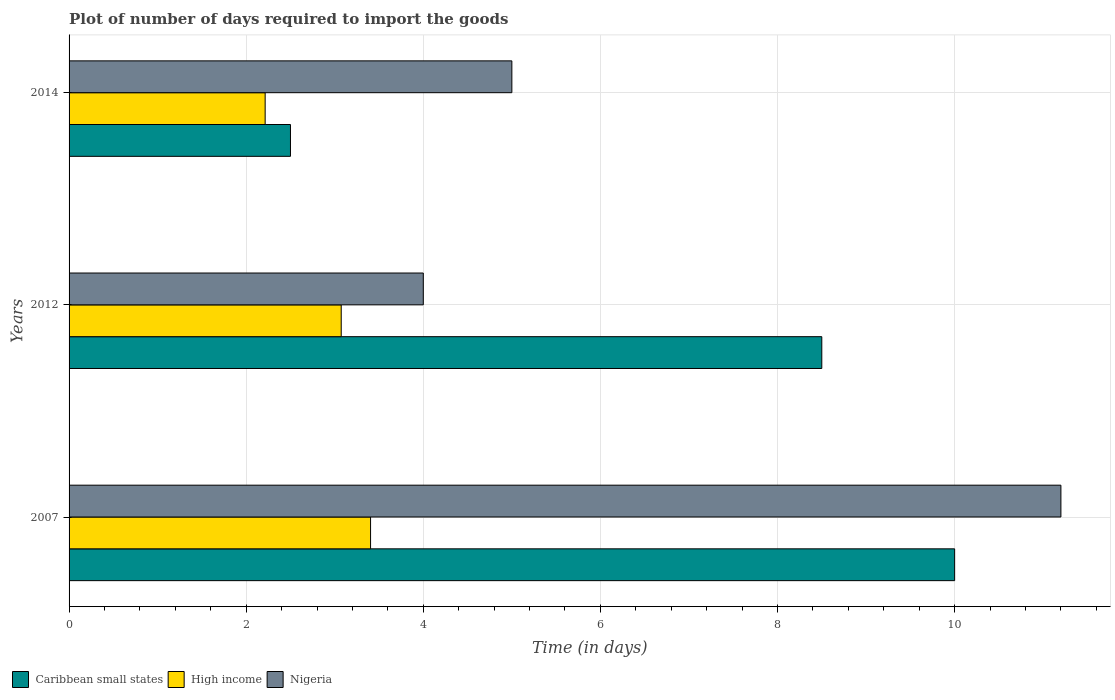How many different coloured bars are there?
Keep it short and to the point. 3. How many groups of bars are there?
Keep it short and to the point. 3. How many bars are there on the 3rd tick from the bottom?
Give a very brief answer. 3. What is the label of the 2nd group of bars from the top?
Keep it short and to the point. 2012. What is the time required to import goods in High income in 2012?
Keep it short and to the point. 3.07. Across all years, what is the maximum time required to import goods in Caribbean small states?
Ensure brevity in your answer.  10. Across all years, what is the minimum time required to import goods in High income?
Keep it short and to the point. 2.21. What is the difference between the time required to import goods in Nigeria in 2014 and the time required to import goods in High income in 2012?
Your answer should be compact. 1.93. What is the average time required to import goods in Nigeria per year?
Ensure brevity in your answer.  6.73. In the year 2014, what is the difference between the time required to import goods in Nigeria and time required to import goods in Caribbean small states?
Give a very brief answer. 2.5. What is the ratio of the time required to import goods in High income in 2007 to that in 2012?
Offer a terse response. 1.11. Is the time required to import goods in Caribbean small states in 2007 less than that in 2014?
Your answer should be compact. No. Is the difference between the time required to import goods in Nigeria in 2012 and 2014 greater than the difference between the time required to import goods in Caribbean small states in 2012 and 2014?
Make the answer very short. No. What is the difference between the highest and the second highest time required to import goods in Nigeria?
Your answer should be compact. 6.2. In how many years, is the time required to import goods in Caribbean small states greater than the average time required to import goods in Caribbean small states taken over all years?
Ensure brevity in your answer.  2. What does the 3rd bar from the top in 2012 represents?
Make the answer very short. Caribbean small states. How many years are there in the graph?
Keep it short and to the point. 3. What is the difference between two consecutive major ticks on the X-axis?
Make the answer very short. 2. Does the graph contain any zero values?
Make the answer very short. No. Does the graph contain grids?
Offer a terse response. Yes. Where does the legend appear in the graph?
Your answer should be very brief. Bottom left. How are the legend labels stacked?
Your response must be concise. Horizontal. What is the title of the graph?
Your answer should be very brief. Plot of number of days required to import the goods. What is the label or title of the X-axis?
Provide a short and direct response. Time (in days). What is the label or title of the Y-axis?
Provide a succinct answer. Years. What is the Time (in days) of High income in 2007?
Your response must be concise. 3.4. What is the Time (in days) of Nigeria in 2007?
Your answer should be compact. 11.2. What is the Time (in days) in Caribbean small states in 2012?
Offer a very short reply. 8.5. What is the Time (in days) in High income in 2012?
Ensure brevity in your answer.  3.07. What is the Time (in days) of Nigeria in 2012?
Offer a terse response. 4. What is the Time (in days) in High income in 2014?
Make the answer very short. 2.21. What is the Time (in days) of Nigeria in 2014?
Your answer should be compact. 5. Across all years, what is the maximum Time (in days) of High income?
Provide a succinct answer. 3.4. Across all years, what is the minimum Time (in days) in Caribbean small states?
Your answer should be very brief. 2.5. Across all years, what is the minimum Time (in days) in High income?
Your answer should be compact. 2.21. What is the total Time (in days) in High income in the graph?
Provide a short and direct response. 8.69. What is the total Time (in days) of Nigeria in the graph?
Your answer should be very brief. 20.2. What is the difference between the Time (in days) of High income in 2007 and that in 2012?
Keep it short and to the point. 0.33. What is the difference between the Time (in days) of Caribbean small states in 2007 and that in 2014?
Offer a terse response. 7.5. What is the difference between the Time (in days) of High income in 2007 and that in 2014?
Provide a succinct answer. 1.19. What is the difference between the Time (in days) in High income in 2012 and that in 2014?
Your answer should be very brief. 0.86. What is the difference between the Time (in days) of Caribbean small states in 2007 and the Time (in days) of High income in 2012?
Provide a succinct answer. 6.93. What is the difference between the Time (in days) in Caribbean small states in 2007 and the Time (in days) in Nigeria in 2012?
Your answer should be very brief. 6. What is the difference between the Time (in days) of High income in 2007 and the Time (in days) of Nigeria in 2012?
Your answer should be very brief. -0.6. What is the difference between the Time (in days) of Caribbean small states in 2007 and the Time (in days) of High income in 2014?
Give a very brief answer. 7.79. What is the difference between the Time (in days) of High income in 2007 and the Time (in days) of Nigeria in 2014?
Give a very brief answer. -1.6. What is the difference between the Time (in days) in Caribbean small states in 2012 and the Time (in days) in High income in 2014?
Keep it short and to the point. 6.29. What is the difference between the Time (in days) of Caribbean small states in 2012 and the Time (in days) of Nigeria in 2014?
Your answer should be very brief. 3.5. What is the difference between the Time (in days) in High income in 2012 and the Time (in days) in Nigeria in 2014?
Provide a succinct answer. -1.93. What is the average Time (in days) of High income per year?
Offer a terse response. 2.9. What is the average Time (in days) in Nigeria per year?
Give a very brief answer. 6.73. In the year 2007, what is the difference between the Time (in days) of Caribbean small states and Time (in days) of High income?
Provide a succinct answer. 6.6. In the year 2007, what is the difference between the Time (in days) of High income and Time (in days) of Nigeria?
Your answer should be very brief. -7.8. In the year 2012, what is the difference between the Time (in days) in Caribbean small states and Time (in days) in High income?
Offer a very short reply. 5.43. In the year 2012, what is the difference between the Time (in days) in Caribbean small states and Time (in days) in Nigeria?
Offer a terse response. 4.5. In the year 2012, what is the difference between the Time (in days) of High income and Time (in days) of Nigeria?
Give a very brief answer. -0.93. In the year 2014, what is the difference between the Time (in days) in Caribbean small states and Time (in days) in High income?
Offer a terse response. 0.29. In the year 2014, what is the difference between the Time (in days) of High income and Time (in days) of Nigeria?
Offer a terse response. -2.79. What is the ratio of the Time (in days) of Caribbean small states in 2007 to that in 2012?
Your answer should be very brief. 1.18. What is the ratio of the Time (in days) in High income in 2007 to that in 2012?
Keep it short and to the point. 1.11. What is the ratio of the Time (in days) in Nigeria in 2007 to that in 2012?
Offer a very short reply. 2.8. What is the ratio of the Time (in days) in Caribbean small states in 2007 to that in 2014?
Make the answer very short. 4. What is the ratio of the Time (in days) in High income in 2007 to that in 2014?
Your response must be concise. 1.54. What is the ratio of the Time (in days) of Nigeria in 2007 to that in 2014?
Your response must be concise. 2.24. What is the ratio of the Time (in days) in High income in 2012 to that in 2014?
Provide a short and direct response. 1.39. What is the ratio of the Time (in days) in Nigeria in 2012 to that in 2014?
Your answer should be compact. 0.8. What is the difference between the highest and the second highest Time (in days) of Caribbean small states?
Offer a very short reply. 1.5. What is the difference between the highest and the second highest Time (in days) in High income?
Ensure brevity in your answer.  0.33. What is the difference between the highest and the lowest Time (in days) of Caribbean small states?
Your response must be concise. 7.5. What is the difference between the highest and the lowest Time (in days) of High income?
Provide a short and direct response. 1.19. What is the difference between the highest and the lowest Time (in days) of Nigeria?
Keep it short and to the point. 7.2. 